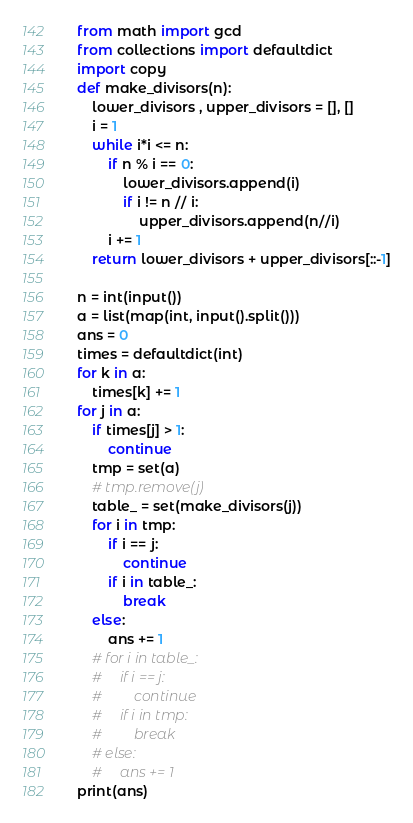<code> <loc_0><loc_0><loc_500><loc_500><_Python_>from math import gcd
from collections import defaultdict
import copy
def make_divisors(n):
    lower_divisors , upper_divisors = [], []
    i = 1
    while i*i <= n:
        if n % i == 0:
            lower_divisors.append(i)
            if i != n // i:
                upper_divisors.append(n//i)
        i += 1
    return lower_divisors + upper_divisors[::-1]

n = int(input())
a = list(map(int, input().split()))
ans = 0
times = defaultdict(int)
for k in a:
    times[k] += 1
for j in a:
    if times[j] > 1:
        continue
    tmp = set(a)
    # tmp.remove(j)
    table_ = set(make_divisors(j))
    for i in tmp:
        if i == j:
            continue
        if i in table_:
            break
    else:
        ans += 1
    # for i in table_:
    #     if i == j:
    #         continue
    #     if i in tmp:
    #         break
    # else:
    #     ans += 1
print(ans)</code> 